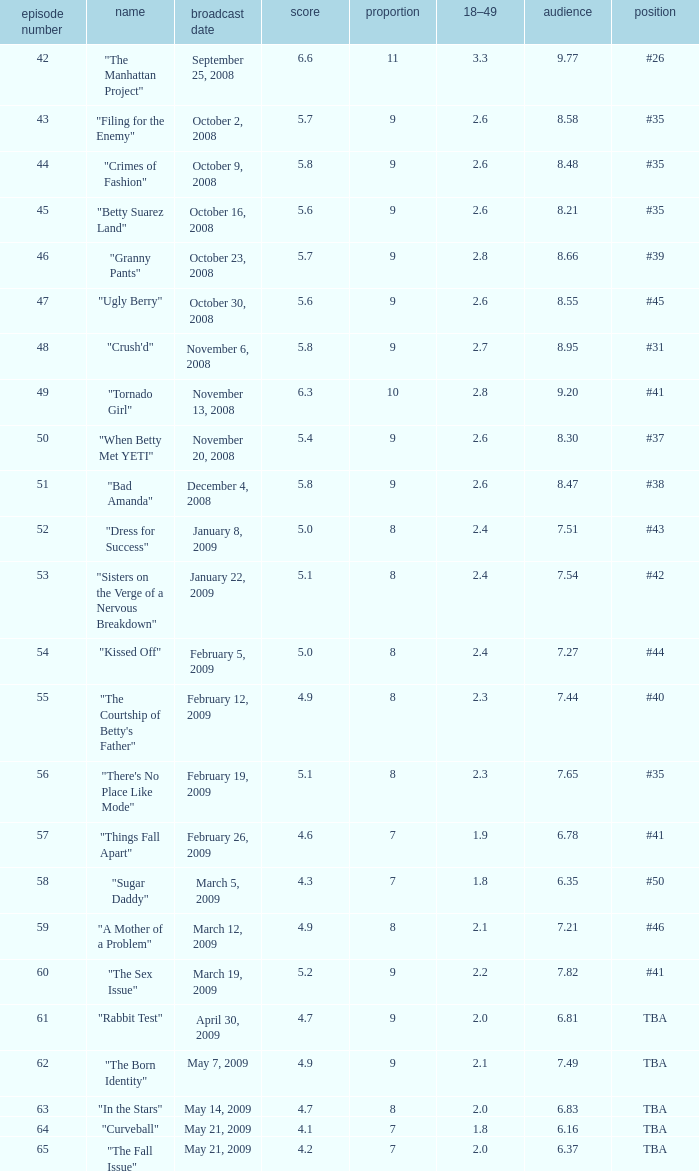What is the Air Date that has a 18–49 larger than 1.9, less than 7.54 viewers and a rating less than 4.9? April 30, 2009, May 14, 2009, May 21, 2009. 